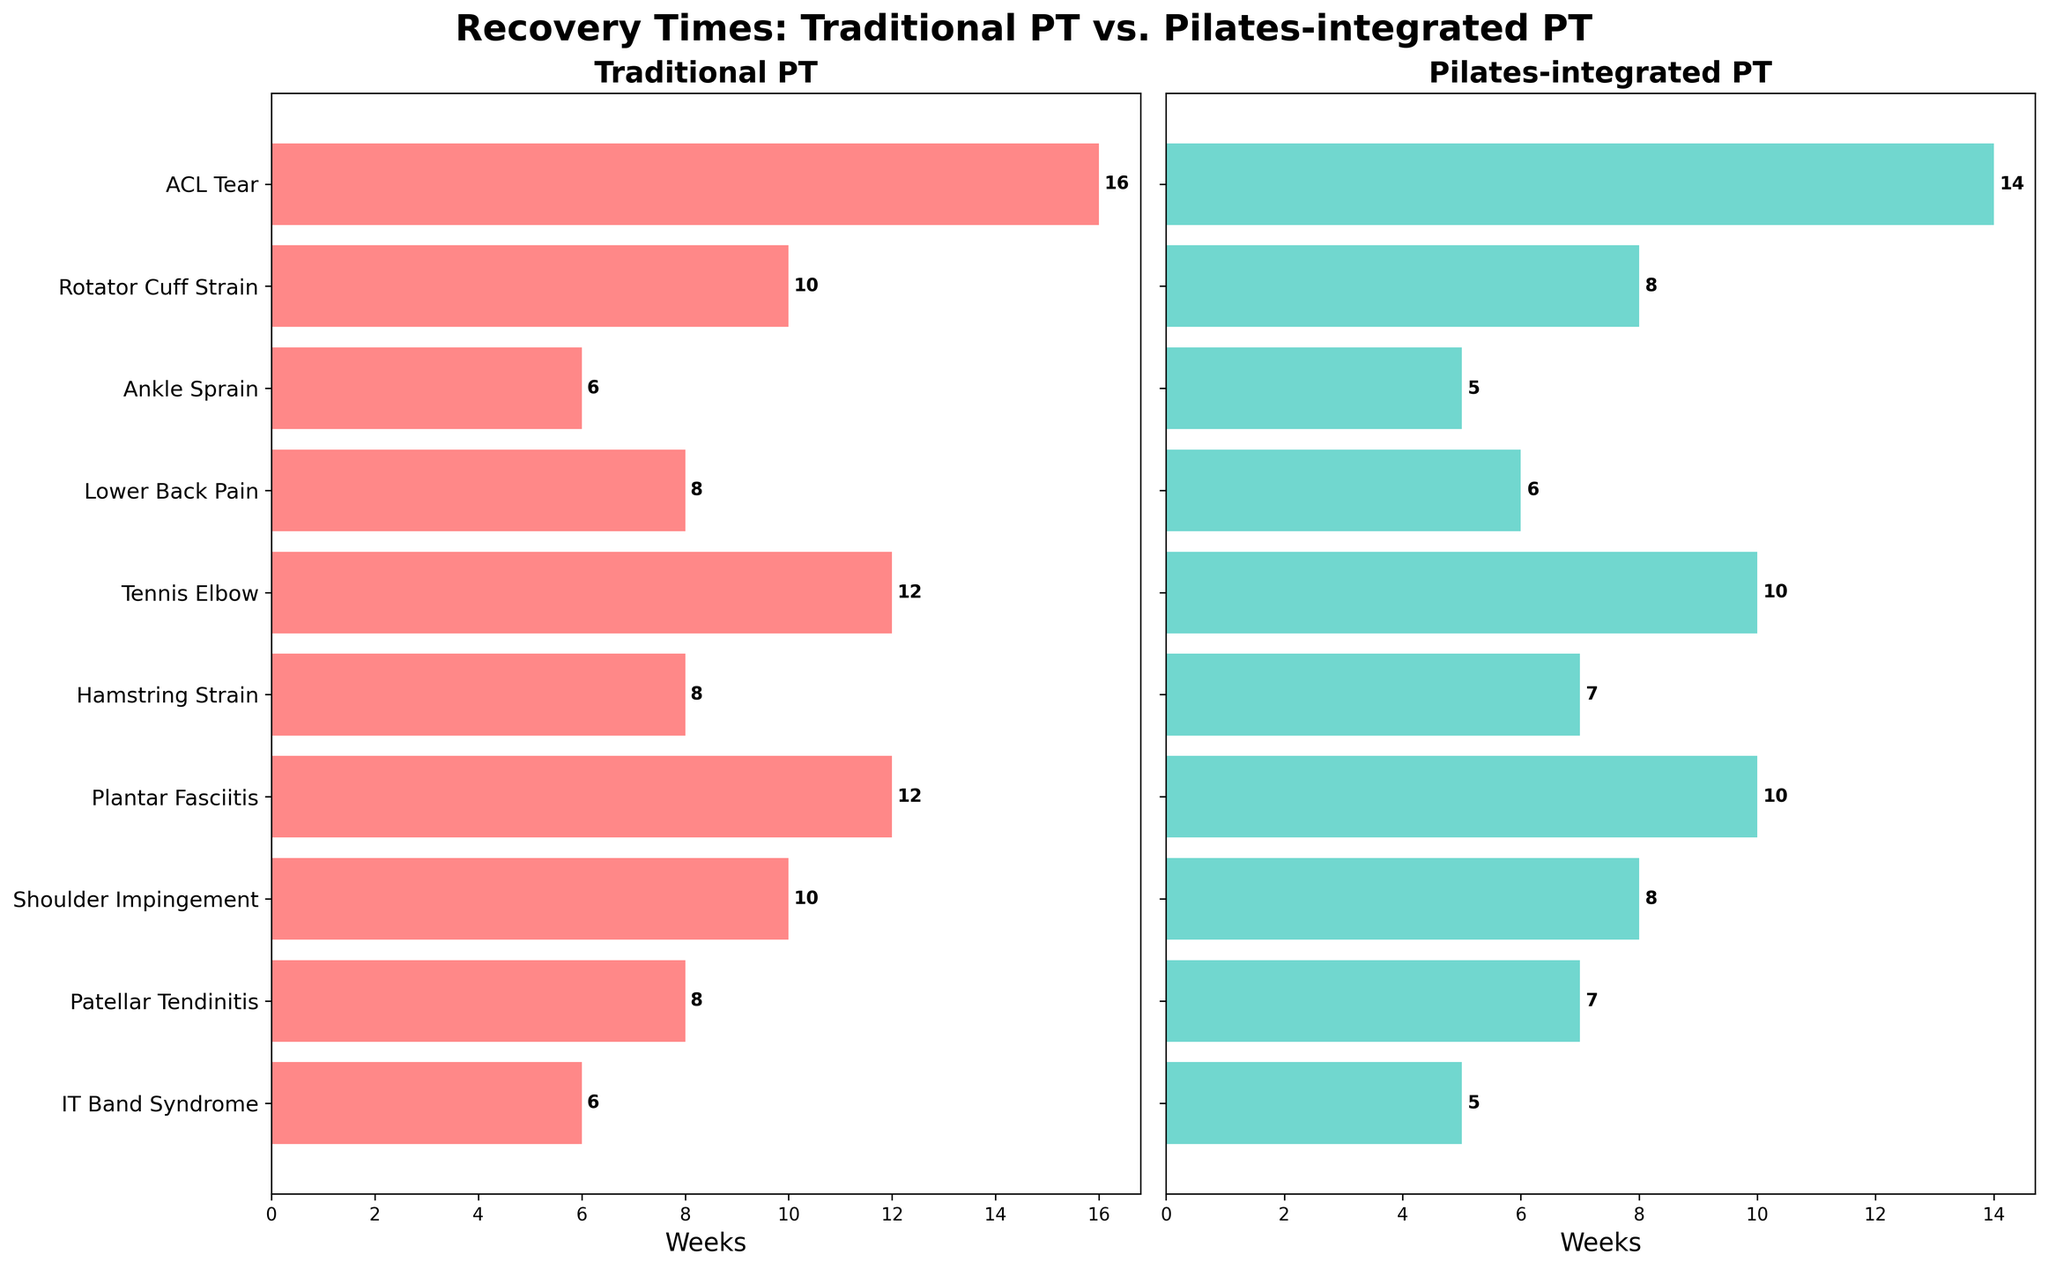How many injuries are compared in the figure? The figure shows a list of injuries on the y-axis for both traditional PT and Pilates-integrated PT. By counting the injuries listed, we can determine the number of injuries compared.
Answer: 10 Which treatment shows a lower average recovery time across all injuries? Calculate the average recovery time for both traditional PT and Pilates-integrated PT by summing their respective recovery times and dividing by the number of injuries. Traditional PT total: 16+10+6+8+12+8+12+10+8+6 = 96 weeks. Average: 96/10 = 9.6 weeks. Pilates-integrated PT total: 14+8+5+6+10+7+10+8+7+5 = 80 weeks. Average: 80/10 = 8 weeks. Compare the averages to determine which is lower.
Answer: Pilates-integrated PT What is the difference in recovery time for a Rotator Cuff Strain between Traditional PT and Pilates-integrated PT? Subtract the recovery time for Pilates-integrated PT from the recovery time for Traditional PT for Rotator Cuff Strain: 10 weeks (Traditional PT) - 8 weeks (Pilates-integrated PT).
Answer: 2 weeks For which injury is the recovery time the same for both treatment methods? Compare the recovery times for each injury between Traditional PT and Pilates-integrated PT. If the recovery times are equal, note it down. In this case, no injury has the same recovery time for both treatments.
Answer: None Which injury has the highest recovery time in Traditional PT, and what is this time? Look at the bar lengths and the numerical labels on the bars in Traditional PT subplot to identify the injury with the highest recovery time and its corresponding value.
Answer: ACL Tear, 16 weeks Compare the recovery times for Tennis Elbow between the two treatments. Which one is faster? Read the recovery times for Tennis Elbow from both subplots and compare them. Traditional PT shows 12 weeks, and Pilates-integrated PT shows 10 weeks. Pilates-integrated PT is faster.
Answer: Pilates-integrated PT What is the total combined recovery time for all injuries using Pilates-integrated PT? Sum up the recovery times for Pilates-integrated PT across all injuries: 14 + 8 + 5 + 6 + 10 + 7 + 10 + 8 + 7 + 5.
Answer: 80 weeks How much faster, on average, is Pilates-integrated PT compared to Traditional PT for all injuries? Determine the average recovery time for both Traditional PT and Pilates-integrated PT, then subtract the average of Pilates-integrated PT from the average of Traditional PT: 9.6 - 8 = 1.6 weeks.
Answer: 1.6 weeks For which injury is the recovery time reduced by 2 weeks when using Pilates-integrated PT compared to Traditional PT? Compare the recovery times for each injury between Traditional PT and Pilates-integrated PT and identify which injury has a difference of 2 weeks. Injuries with a 2-week reduction are Rotator Cuff Strain, Tennis Elbow, and Shoulder Impingement.
Answer: Rotator Cuff Strain, Tennis Elbow, Shoulder Impingement Which injury has the shortest recovery time under Pilates-integrated PT and what is this time? Look at the bar lengths and the numerical labels on the bars in the Pilates-integrated PT subplot to identify the injury with the shortest recovery time and its corresponding value.
Answer: Ankle Sprain and IT Band Syndrome, 5 weeks 